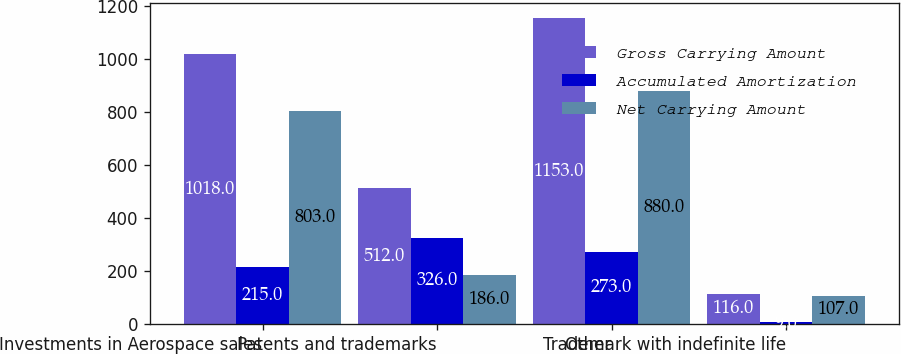Convert chart. <chart><loc_0><loc_0><loc_500><loc_500><stacked_bar_chart><ecel><fcel>Investments in Aerospace sales<fcel>Patents and trademarks<fcel>Other<fcel>Trademark with indefinite life<nl><fcel>Gross Carrying Amount<fcel>1018<fcel>512<fcel>1153<fcel>116<nl><fcel>Accumulated Amortization<fcel>215<fcel>326<fcel>273<fcel>9<nl><fcel>Net Carrying Amount<fcel>803<fcel>186<fcel>880<fcel>107<nl></chart> 